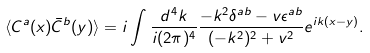Convert formula to latex. <formula><loc_0><loc_0><loc_500><loc_500>\langle C ^ { a } ( x ) \bar { C } ^ { b } ( y ) \rangle = i \int \frac { d ^ { 4 } k } { i ( 2 \pi ) ^ { 4 } } \frac { - k ^ { 2 } \delta ^ { a b } - v \epsilon ^ { a b } } { ( - k ^ { 2 } ) ^ { 2 } + v ^ { 2 } } e ^ { i k ( x - y ) } .</formula> 